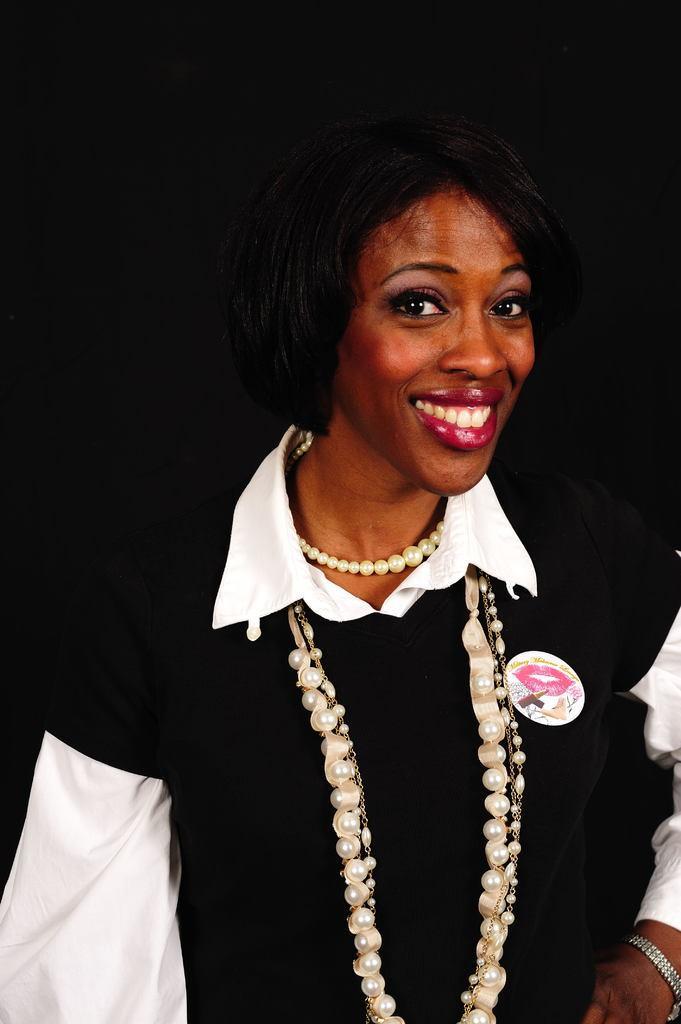Can you describe this image briefly? In this picture we can see a woman wearing jewelry. 